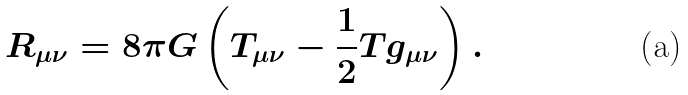Convert formula to latex. <formula><loc_0><loc_0><loc_500><loc_500>R _ { \mu \nu } = 8 \pi G \left ( T _ { \mu \nu } - \frac { 1 } { 2 } T g _ { \mu \nu } \right ) .</formula> 